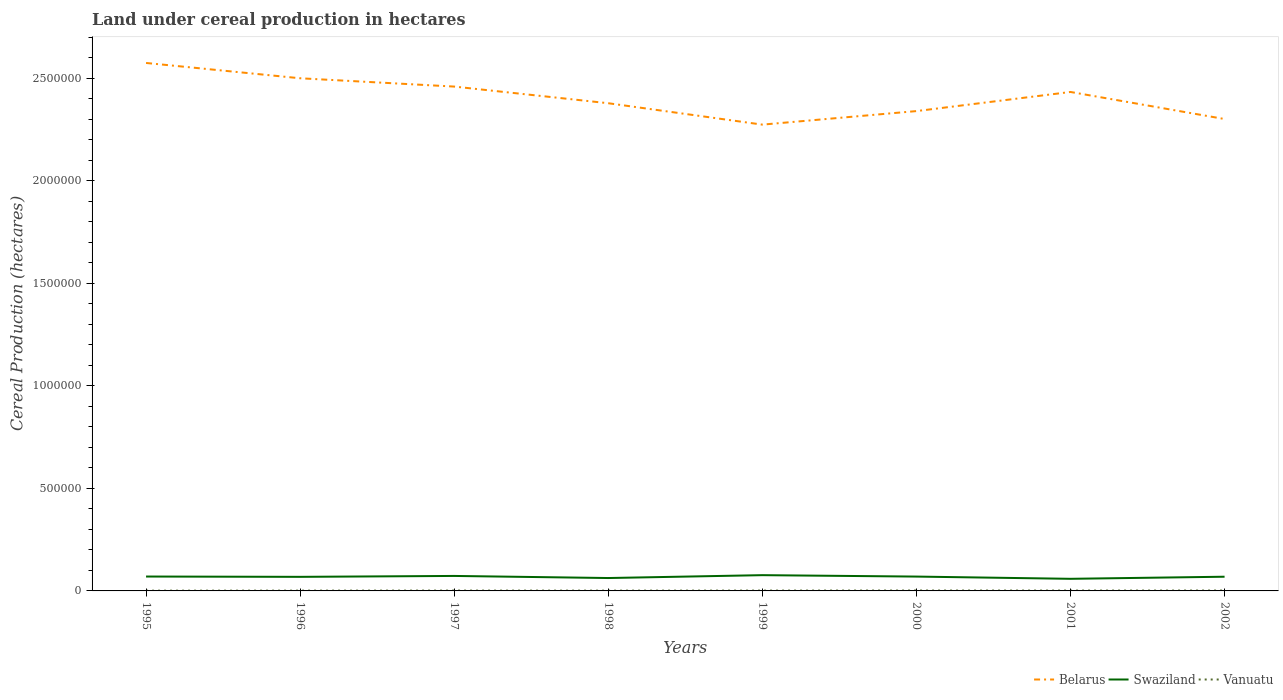How many different coloured lines are there?
Make the answer very short. 3. Across all years, what is the maximum land under cereal production in Swaziland?
Offer a terse response. 5.90e+04. What is the total land under cereal production in Belarus in the graph?
Provide a succinct answer. 1.99e+05. What is the difference between the highest and the second highest land under cereal production in Vanuatu?
Ensure brevity in your answer.  650. What is the difference between the highest and the lowest land under cereal production in Swaziland?
Your answer should be compact. 5. Is the land under cereal production in Swaziland strictly greater than the land under cereal production in Vanuatu over the years?
Give a very brief answer. No. How many lines are there?
Make the answer very short. 3. How many years are there in the graph?
Your response must be concise. 8. Are the values on the major ticks of Y-axis written in scientific E-notation?
Your answer should be very brief. No. Where does the legend appear in the graph?
Provide a short and direct response. Bottom right. How are the legend labels stacked?
Your answer should be very brief. Horizontal. What is the title of the graph?
Make the answer very short. Land under cereal production in hectares. What is the label or title of the Y-axis?
Offer a terse response. Cereal Production (hectares). What is the Cereal Production (hectares) in Belarus in 1995?
Offer a very short reply. 2.57e+06. What is the Cereal Production (hectares) in Swaziland in 1995?
Provide a short and direct response. 7.01e+04. What is the Cereal Production (hectares) of Vanuatu in 1995?
Provide a succinct answer. 1306. What is the Cereal Production (hectares) of Belarus in 1996?
Your answer should be very brief. 2.50e+06. What is the Cereal Production (hectares) of Swaziland in 1996?
Offer a terse response. 6.87e+04. What is the Cereal Production (hectares) of Vanuatu in 1996?
Ensure brevity in your answer.  1466. What is the Cereal Production (hectares) of Belarus in 1997?
Offer a terse response. 2.46e+06. What is the Cereal Production (hectares) in Swaziland in 1997?
Ensure brevity in your answer.  7.30e+04. What is the Cereal Production (hectares) of Vanuatu in 1997?
Offer a terse response. 1693. What is the Cereal Production (hectares) of Belarus in 1998?
Your answer should be very brief. 2.38e+06. What is the Cereal Production (hectares) in Swaziland in 1998?
Your response must be concise. 6.28e+04. What is the Cereal Production (hectares) in Vanuatu in 1998?
Keep it short and to the point. 1458. What is the Cereal Production (hectares) in Belarus in 1999?
Make the answer very short. 2.27e+06. What is the Cereal Production (hectares) in Swaziland in 1999?
Provide a succinct answer. 7.68e+04. What is the Cereal Production (hectares) in Vanuatu in 1999?
Provide a short and direct response. 1672. What is the Cereal Production (hectares) in Belarus in 2000?
Make the answer very short. 2.34e+06. What is the Cereal Production (hectares) in Swaziland in 2000?
Keep it short and to the point. 6.99e+04. What is the Cereal Production (hectares) in Vanuatu in 2000?
Give a very brief answer. 1956. What is the Cereal Production (hectares) in Belarus in 2001?
Offer a very short reply. 2.43e+06. What is the Cereal Production (hectares) in Swaziland in 2001?
Your response must be concise. 5.90e+04. What is the Cereal Production (hectares) of Vanuatu in 2001?
Make the answer very short. 1781. What is the Cereal Production (hectares) in Belarus in 2002?
Provide a short and direct response. 2.30e+06. What is the Cereal Production (hectares) in Swaziland in 2002?
Your response must be concise. 6.92e+04. What is the Cereal Production (hectares) of Vanuatu in 2002?
Ensure brevity in your answer.  1902. Across all years, what is the maximum Cereal Production (hectares) in Belarus?
Your answer should be compact. 2.57e+06. Across all years, what is the maximum Cereal Production (hectares) in Swaziland?
Make the answer very short. 7.68e+04. Across all years, what is the maximum Cereal Production (hectares) in Vanuatu?
Make the answer very short. 1956. Across all years, what is the minimum Cereal Production (hectares) of Belarus?
Your response must be concise. 2.27e+06. Across all years, what is the minimum Cereal Production (hectares) of Swaziland?
Provide a short and direct response. 5.90e+04. Across all years, what is the minimum Cereal Production (hectares) of Vanuatu?
Provide a short and direct response. 1306. What is the total Cereal Production (hectares) of Belarus in the graph?
Offer a terse response. 1.93e+07. What is the total Cereal Production (hectares) of Swaziland in the graph?
Provide a short and direct response. 5.50e+05. What is the total Cereal Production (hectares) in Vanuatu in the graph?
Offer a very short reply. 1.32e+04. What is the difference between the Cereal Production (hectares) of Belarus in 1995 and that in 1996?
Your response must be concise. 7.46e+04. What is the difference between the Cereal Production (hectares) of Swaziland in 1995 and that in 1996?
Offer a terse response. 1472. What is the difference between the Cereal Production (hectares) in Vanuatu in 1995 and that in 1996?
Provide a short and direct response. -160. What is the difference between the Cereal Production (hectares) in Belarus in 1995 and that in 1997?
Your response must be concise. 1.15e+05. What is the difference between the Cereal Production (hectares) of Swaziland in 1995 and that in 1997?
Offer a very short reply. -2895. What is the difference between the Cereal Production (hectares) in Vanuatu in 1995 and that in 1997?
Keep it short and to the point. -387. What is the difference between the Cereal Production (hectares) of Belarus in 1995 and that in 1998?
Your response must be concise. 1.96e+05. What is the difference between the Cereal Production (hectares) in Swaziland in 1995 and that in 1998?
Make the answer very short. 7324. What is the difference between the Cereal Production (hectares) of Vanuatu in 1995 and that in 1998?
Keep it short and to the point. -152. What is the difference between the Cereal Production (hectares) in Belarus in 1995 and that in 1999?
Provide a succinct answer. 3.01e+05. What is the difference between the Cereal Production (hectares) of Swaziland in 1995 and that in 1999?
Your answer should be very brief. -6715. What is the difference between the Cereal Production (hectares) in Vanuatu in 1995 and that in 1999?
Keep it short and to the point. -366. What is the difference between the Cereal Production (hectares) of Belarus in 1995 and that in 2000?
Provide a succinct answer. 2.35e+05. What is the difference between the Cereal Production (hectares) in Swaziland in 1995 and that in 2000?
Provide a succinct answer. 229. What is the difference between the Cereal Production (hectares) in Vanuatu in 1995 and that in 2000?
Make the answer very short. -650. What is the difference between the Cereal Production (hectares) of Belarus in 1995 and that in 2001?
Ensure brevity in your answer.  1.41e+05. What is the difference between the Cereal Production (hectares) of Swaziland in 1995 and that in 2001?
Your answer should be very brief. 1.11e+04. What is the difference between the Cereal Production (hectares) in Vanuatu in 1995 and that in 2001?
Your answer should be very brief. -475. What is the difference between the Cereal Production (hectares) of Belarus in 1995 and that in 2002?
Provide a succinct answer. 2.73e+05. What is the difference between the Cereal Production (hectares) in Swaziland in 1995 and that in 2002?
Ensure brevity in your answer.  881. What is the difference between the Cereal Production (hectares) of Vanuatu in 1995 and that in 2002?
Your answer should be compact. -596. What is the difference between the Cereal Production (hectares) in Belarus in 1996 and that in 1997?
Provide a short and direct response. 4.05e+04. What is the difference between the Cereal Production (hectares) of Swaziland in 1996 and that in 1997?
Provide a short and direct response. -4367. What is the difference between the Cereal Production (hectares) in Vanuatu in 1996 and that in 1997?
Give a very brief answer. -227. What is the difference between the Cereal Production (hectares) of Belarus in 1996 and that in 1998?
Provide a short and direct response. 1.22e+05. What is the difference between the Cereal Production (hectares) of Swaziland in 1996 and that in 1998?
Your response must be concise. 5852. What is the difference between the Cereal Production (hectares) of Vanuatu in 1996 and that in 1998?
Offer a very short reply. 8. What is the difference between the Cereal Production (hectares) of Belarus in 1996 and that in 1999?
Offer a terse response. 2.26e+05. What is the difference between the Cereal Production (hectares) in Swaziland in 1996 and that in 1999?
Provide a succinct answer. -8187. What is the difference between the Cereal Production (hectares) in Vanuatu in 1996 and that in 1999?
Your answer should be very brief. -206. What is the difference between the Cereal Production (hectares) of Swaziland in 1996 and that in 2000?
Keep it short and to the point. -1243. What is the difference between the Cereal Production (hectares) in Vanuatu in 1996 and that in 2000?
Your answer should be very brief. -490. What is the difference between the Cereal Production (hectares) in Belarus in 1996 and that in 2001?
Provide a short and direct response. 6.68e+04. What is the difference between the Cereal Production (hectares) in Swaziland in 1996 and that in 2001?
Your response must be concise. 9651. What is the difference between the Cereal Production (hectares) of Vanuatu in 1996 and that in 2001?
Provide a succinct answer. -315. What is the difference between the Cereal Production (hectares) in Belarus in 1996 and that in 2002?
Provide a succinct answer. 1.99e+05. What is the difference between the Cereal Production (hectares) of Swaziland in 1996 and that in 2002?
Ensure brevity in your answer.  -591. What is the difference between the Cereal Production (hectares) of Vanuatu in 1996 and that in 2002?
Keep it short and to the point. -436. What is the difference between the Cereal Production (hectares) of Belarus in 1997 and that in 1998?
Your response must be concise. 8.12e+04. What is the difference between the Cereal Production (hectares) in Swaziland in 1997 and that in 1998?
Give a very brief answer. 1.02e+04. What is the difference between the Cereal Production (hectares) in Vanuatu in 1997 and that in 1998?
Your response must be concise. 235. What is the difference between the Cereal Production (hectares) in Belarus in 1997 and that in 1999?
Your answer should be very brief. 1.86e+05. What is the difference between the Cereal Production (hectares) in Swaziland in 1997 and that in 1999?
Provide a succinct answer. -3820. What is the difference between the Cereal Production (hectares) of Vanuatu in 1997 and that in 1999?
Provide a short and direct response. 21. What is the difference between the Cereal Production (hectares) in Belarus in 1997 and that in 2000?
Your answer should be compact. 1.20e+05. What is the difference between the Cereal Production (hectares) of Swaziland in 1997 and that in 2000?
Make the answer very short. 3124. What is the difference between the Cereal Production (hectares) in Vanuatu in 1997 and that in 2000?
Your answer should be compact. -263. What is the difference between the Cereal Production (hectares) of Belarus in 1997 and that in 2001?
Offer a terse response. 2.63e+04. What is the difference between the Cereal Production (hectares) of Swaziland in 1997 and that in 2001?
Keep it short and to the point. 1.40e+04. What is the difference between the Cereal Production (hectares) of Vanuatu in 1997 and that in 2001?
Keep it short and to the point. -88. What is the difference between the Cereal Production (hectares) of Belarus in 1997 and that in 2002?
Ensure brevity in your answer.  1.58e+05. What is the difference between the Cereal Production (hectares) in Swaziland in 1997 and that in 2002?
Your answer should be very brief. 3776. What is the difference between the Cereal Production (hectares) in Vanuatu in 1997 and that in 2002?
Offer a terse response. -209. What is the difference between the Cereal Production (hectares) in Belarus in 1998 and that in 1999?
Offer a terse response. 1.04e+05. What is the difference between the Cereal Production (hectares) of Swaziland in 1998 and that in 1999?
Make the answer very short. -1.40e+04. What is the difference between the Cereal Production (hectares) of Vanuatu in 1998 and that in 1999?
Keep it short and to the point. -214. What is the difference between the Cereal Production (hectares) of Belarus in 1998 and that in 2000?
Provide a succinct answer. 3.83e+04. What is the difference between the Cereal Production (hectares) of Swaziland in 1998 and that in 2000?
Offer a very short reply. -7095. What is the difference between the Cereal Production (hectares) in Vanuatu in 1998 and that in 2000?
Ensure brevity in your answer.  -498. What is the difference between the Cereal Production (hectares) of Belarus in 1998 and that in 2001?
Give a very brief answer. -5.49e+04. What is the difference between the Cereal Production (hectares) of Swaziland in 1998 and that in 2001?
Offer a very short reply. 3799. What is the difference between the Cereal Production (hectares) of Vanuatu in 1998 and that in 2001?
Your response must be concise. -323. What is the difference between the Cereal Production (hectares) of Belarus in 1998 and that in 2002?
Your answer should be compact. 7.70e+04. What is the difference between the Cereal Production (hectares) of Swaziland in 1998 and that in 2002?
Make the answer very short. -6443. What is the difference between the Cereal Production (hectares) in Vanuatu in 1998 and that in 2002?
Provide a short and direct response. -444. What is the difference between the Cereal Production (hectares) in Belarus in 1999 and that in 2000?
Give a very brief answer. -6.60e+04. What is the difference between the Cereal Production (hectares) in Swaziland in 1999 and that in 2000?
Make the answer very short. 6944. What is the difference between the Cereal Production (hectares) of Vanuatu in 1999 and that in 2000?
Your answer should be very brief. -284. What is the difference between the Cereal Production (hectares) in Belarus in 1999 and that in 2001?
Your answer should be very brief. -1.59e+05. What is the difference between the Cereal Production (hectares) in Swaziland in 1999 and that in 2001?
Keep it short and to the point. 1.78e+04. What is the difference between the Cereal Production (hectares) of Vanuatu in 1999 and that in 2001?
Make the answer very short. -109. What is the difference between the Cereal Production (hectares) of Belarus in 1999 and that in 2002?
Offer a very short reply. -2.73e+04. What is the difference between the Cereal Production (hectares) of Swaziland in 1999 and that in 2002?
Ensure brevity in your answer.  7596. What is the difference between the Cereal Production (hectares) of Vanuatu in 1999 and that in 2002?
Offer a terse response. -230. What is the difference between the Cereal Production (hectares) of Belarus in 2000 and that in 2001?
Provide a short and direct response. -9.32e+04. What is the difference between the Cereal Production (hectares) in Swaziland in 2000 and that in 2001?
Your response must be concise. 1.09e+04. What is the difference between the Cereal Production (hectares) in Vanuatu in 2000 and that in 2001?
Make the answer very short. 175. What is the difference between the Cereal Production (hectares) of Belarus in 2000 and that in 2002?
Offer a terse response. 3.87e+04. What is the difference between the Cereal Production (hectares) of Swaziland in 2000 and that in 2002?
Provide a short and direct response. 652. What is the difference between the Cereal Production (hectares) of Belarus in 2001 and that in 2002?
Keep it short and to the point. 1.32e+05. What is the difference between the Cereal Production (hectares) in Swaziland in 2001 and that in 2002?
Offer a terse response. -1.02e+04. What is the difference between the Cereal Production (hectares) of Vanuatu in 2001 and that in 2002?
Ensure brevity in your answer.  -121. What is the difference between the Cereal Production (hectares) of Belarus in 1995 and the Cereal Production (hectares) of Swaziland in 1996?
Make the answer very short. 2.50e+06. What is the difference between the Cereal Production (hectares) in Belarus in 1995 and the Cereal Production (hectares) in Vanuatu in 1996?
Offer a terse response. 2.57e+06. What is the difference between the Cereal Production (hectares) of Swaziland in 1995 and the Cereal Production (hectares) of Vanuatu in 1996?
Your answer should be compact. 6.87e+04. What is the difference between the Cereal Production (hectares) in Belarus in 1995 and the Cereal Production (hectares) in Swaziland in 1997?
Make the answer very short. 2.50e+06. What is the difference between the Cereal Production (hectares) in Belarus in 1995 and the Cereal Production (hectares) in Vanuatu in 1997?
Your answer should be very brief. 2.57e+06. What is the difference between the Cereal Production (hectares) in Swaziland in 1995 and the Cereal Production (hectares) in Vanuatu in 1997?
Provide a succinct answer. 6.84e+04. What is the difference between the Cereal Production (hectares) in Belarus in 1995 and the Cereal Production (hectares) in Swaziland in 1998?
Ensure brevity in your answer.  2.51e+06. What is the difference between the Cereal Production (hectares) in Belarus in 1995 and the Cereal Production (hectares) in Vanuatu in 1998?
Your response must be concise. 2.57e+06. What is the difference between the Cereal Production (hectares) in Swaziland in 1995 and the Cereal Production (hectares) in Vanuatu in 1998?
Give a very brief answer. 6.87e+04. What is the difference between the Cereal Production (hectares) of Belarus in 1995 and the Cereal Production (hectares) of Swaziland in 1999?
Provide a succinct answer. 2.50e+06. What is the difference between the Cereal Production (hectares) of Belarus in 1995 and the Cereal Production (hectares) of Vanuatu in 1999?
Make the answer very short. 2.57e+06. What is the difference between the Cereal Production (hectares) in Swaziland in 1995 and the Cereal Production (hectares) in Vanuatu in 1999?
Your answer should be compact. 6.85e+04. What is the difference between the Cereal Production (hectares) in Belarus in 1995 and the Cereal Production (hectares) in Swaziland in 2000?
Give a very brief answer. 2.50e+06. What is the difference between the Cereal Production (hectares) of Belarus in 1995 and the Cereal Production (hectares) of Vanuatu in 2000?
Your answer should be very brief. 2.57e+06. What is the difference between the Cereal Production (hectares) in Swaziland in 1995 and the Cereal Production (hectares) in Vanuatu in 2000?
Keep it short and to the point. 6.82e+04. What is the difference between the Cereal Production (hectares) of Belarus in 1995 and the Cereal Production (hectares) of Swaziland in 2001?
Your answer should be very brief. 2.51e+06. What is the difference between the Cereal Production (hectares) of Belarus in 1995 and the Cereal Production (hectares) of Vanuatu in 2001?
Offer a terse response. 2.57e+06. What is the difference between the Cereal Production (hectares) of Swaziland in 1995 and the Cereal Production (hectares) of Vanuatu in 2001?
Your response must be concise. 6.83e+04. What is the difference between the Cereal Production (hectares) in Belarus in 1995 and the Cereal Production (hectares) in Swaziland in 2002?
Your answer should be compact. 2.50e+06. What is the difference between the Cereal Production (hectares) of Belarus in 1995 and the Cereal Production (hectares) of Vanuatu in 2002?
Your answer should be very brief. 2.57e+06. What is the difference between the Cereal Production (hectares) of Swaziland in 1995 and the Cereal Production (hectares) of Vanuatu in 2002?
Make the answer very short. 6.82e+04. What is the difference between the Cereal Production (hectares) in Belarus in 1996 and the Cereal Production (hectares) in Swaziland in 1997?
Keep it short and to the point. 2.43e+06. What is the difference between the Cereal Production (hectares) in Belarus in 1996 and the Cereal Production (hectares) in Vanuatu in 1997?
Ensure brevity in your answer.  2.50e+06. What is the difference between the Cereal Production (hectares) of Swaziland in 1996 and the Cereal Production (hectares) of Vanuatu in 1997?
Keep it short and to the point. 6.70e+04. What is the difference between the Cereal Production (hectares) in Belarus in 1996 and the Cereal Production (hectares) in Swaziland in 1998?
Ensure brevity in your answer.  2.44e+06. What is the difference between the Cereal Production (hectares) of Belarus in 1996 and the Cereal Production (hectares) of Vanuatu in 1998?
Ensure brevity in your answer.  2.50e+06. What is the difference between the Cereal Production (hectares) of Swaziland in 1996 and the Cereal Production (hectares) of Vanuatu in 1998?
Ensure brevity in your answer.  6.72e+04. What is the difference between the Cereal Production (hectares) in Belarus in 1996 and the Cereal Production (hectares) in Swaziland in 1999?
Provide a short and direct response. 2.42e+06. What is the difference between the Cereal Production (hectares) of Belarus in 1996 and the Cereal Production (hectares) of Vanuatu in 1999?
Keep it short and to the point. 2.50e+06. What is the difference between the Cereal Production (hectares) in Swaziland in 1996 and the Cereal Production (hectares) in Vanuatu in 1999?
Offer a terse response. 6.70e+04. What is the difference between the Cereal Production (hectares) in Belarus in 1996 and the Cereal Production (hectares) in Swaziland in 2000?
Provide a succinct answer. 2.43e+06. What is the difference between the Cereal Production (hectares) of Belarus in 1996 and the Cereal Production (hectares) of Vanuatu in 2000?
Give a very brief answer. 2.50e+06. What is the difference between the Cereal Production (hectares) of Swaziland in 1996 and the Cereal Production (hectares) of Vanuatu in 2000?
Your response must be concise. 6.67e+04. What is the difference between the Cereal Production (hectares) of Belarus in 1996 and the Cereal Production (hectares) of Swaziland in 2001?
Ensure brevity in your answer.  2.44e+06. What is the difference between the Cereal Production (hectares) of Belarus in 1996 and the Cereal Production (hectares) of Vanuatu in 2001?
Ensure brevity in your answer.  2.50e+06. What is the difference between the Cereal Production (hectares) in Swaziland in 1996 and the Cereal Production (hectares) in Vanuatu in 2001?
Give a very brief answer. 6.69e+04. What is the difference between the Cereal Production (hectares) in Belarus in 1996 and the Cereal Production (hectares) in Swaziland in 2002?
Give a very brief answer. 2.43e+06. What is the difference between the Cereal Production (hectares) of Belarus in 1996 and the Cereal Production (hectares) of Vanuatu in 2002?
Provide a short and direct response. 2.50e+06. What is the difference between the Cereal Production (hectares) of Swaziland in 1996 and the Cereal Production (hectares) of Vanuatu in 2002?
Make the answer very short. 6.68e+04. What is the difference between the Cereal Production (hectares) in Belarus in 1997 and the Cereal Production (hectares) in Swaziland in 1998?
Your answer should be very brief. 2.40e+06. What is the difference between the Cereal Production (hectares) in Belarus in 1997 and the Cereal Production (hectares) in Vanuatu in 1998?
Make the answer very short. 2.46e+06. What is the difference between the Cereal Production (hectares) of Swaziland in 1997 and the Cereal Production (hectares) of Vanuatu in 1998?
Provide a succinct answer. 7.16e+04. What is the difference between the Cereal Production (hectares) in Belarus in 1997 and the Cereal Production (hectares) in Swaziland in 1999?
Your response must be concise. 2.38e+06. What is the difference between the Cereal Production (hectares) of Belarus in 1997 and the Cereal Production (hectares) of Vanuatu in 1999?
Keep it short and to the point. 2.46e+06. What is the difference between the Cereal Production (hectares) of Swaziland in 1997 and the Cereal Production (hectares) of Vanuatu in 1999?
Your response must be concise. 7.13e+04. What is the difference between the Cereal Production (hectares) of Belarus in 1997 and the Cereal Production (hectares) of Swaziland in 2000?
Ensure brevity in your answer.  2.39e+06. What is the difference between the Cereal Production (hectares) in Belarus in 1997 and the Cereal Production (hectares) in Vanuatu in 2000?
Provide a short and direct response. 2.46e+06. What is the difference between the Cereal Production (hectares) of Swaziland in 1997 and the Cereal Production (hectares) of Vanuatu in 2000?
Give a very brief answer. 7.11e+04. What is the difference between the Cereal Production (hectares) in Belarus in 1997 and the Cereal Production (hectares) in Swaziland in 2001?
Your answer should be very brief. 2.40e+06. What is the difference between the Cereal Production (hectares) in Belarus in 1997 and the Cereal Production (hectares) in Vanuatu in 2001?
Provide a short and direct response. 2.46e+06. What is the difference between the Cereal Production (hectares) in Swaziland in 1997 and the Cereal Production (hectares) in Vanuatu in 2001?
Ensure brevity in your answer.  7.12e+04. What is the difference between the Cereal Production (hectares) in Belarus in 1997 and the Cereal Production (hectares) in Swaziland in 2002?
Your response must be concise. 2.39e+06. What is the difference between the Cereal Production (hectares) of Belarus in 1997 and the Cereal Production (hectares) of Vanuatu in 2002?
Your answer should be very brief. 2.46e+06. What is the difference between the Cereal Production (hectares) of Swaziland in 1997 and the Cereal Production (hectares) of Vanuatu in 2002?
Ensure brevity in your answer.  7.11e+04. What is the difference between the Cereal Production (hectares) in Belarus in 1998 and the Cereal Production (hectares) in Swaziland in 1999?
Your answer should be very brief. 2.30e+06. What is the difference between the Cereal Production (hectares) of Belarus in 1998 and the Cereal Production (hectares) of Vanuatu in 1999?
Your answer should be very brief. 2.38e+06. What is the difference between the Cereal Production (hectares) in Swaziland in 1998 and the Cereal Production (hectares) in Vanuatu in 1999?
Provide a succinct answer. 6.11e+04. What is the difference between the Cereal Production (hectares) in Belarus in 1998 and the Cereal Production (hectares) in Swaziland in 2000?
Offer a terse response. 2.31e+06. What is the difference between the Cereal Production (hectares) of Belarus in 1998 and the Cereal Production (hectares) of Vanuatu in 2000?
Your response must be concise. 2.38e+06. What is the difference between the Cereal Production (hectares) of Swaziland in 1998 and the Cereal Production (hectares) of Vanuatu in 2000?
Offer a terse response. 6.08e+04. What is the difference between the Cereal Production (hectares) of Belarus in 1998 and the Cereal Production (hectares) of Swaziland in 2001?
Your answer should be very brief. 2.32e+06. What is the difference between the Cereal Production (hectares) in Belarus in 1998 and the Cereal Production (hectares) in Vanuatu in 2001?
Your answer should be very brief. 2.38e+06. What is the difference between the Cereal Production (hectares) in Swaziland in 1998 and the Cereal Production (hectares) in Vanuatu in 2001?
Offer a very short reply. 6.10e+04. What is the difference between the Cereal Production (hectares) of Belarus in 1998 and the Cereal Production (hectares) of Swaziland in 2002?
Your answer should be very brief. 2.31e+06. What is the difference between the Cereal Production (hectares) in Belarus in 1998 and the Cereal Production (hectares) in Vanuatu in 2002?
Your answer should be very brief. 2.38e+06. What is the difference between the Cereal Production (hectares) in Swaziland in 1998 and the Cereal Production (hectares) in Vanuatu in 2002?
Provide a short and direct response. 6.09e+04. What is the difference between the Cereal Production (hectares) in Belarus in 1999 and the Cereal Production (hectares) in Swaziland in 2000?
Keep it short and to the point. 2.20e+06. What is the difference between the Cereal Production (hectares) of Belarus in 1999 and the Cereal Production (hectares) of Vanuatu in 2000?
Your answer should be compact. 2.27e+06. What is the difference between the Cereal Production (hectares) of Swaziland in 1999 and the Cereal Production (hectares) of Vanuatu in 2000?
Your answer should be compact. 7.49e+04. What is the difference between the Cereal Production (hectares) in Belarus in 1999 and the Cereal Production (hectares) in Swaziland in 2001?
Keep it short and to the point. 2.21e+06. What is the difference between the Cereal Production (hectares) of Belarus in 1999 and the Cereal Production (hectares) of Vanuatu in 2001?
Make the answer very short. 2.27e+06. What is the difference between the Cereal Production (hectares) in Swaziland in 1999 and the Cereal Production (hectares) in Vanuatu in 2001?
Give a very brief answer. 7.51e+04. What is the difference between the Cereal Production (hectares) of Belarus in 1999 and the Cereal Production (hectares) of Swaziland in 2002?
Offer a terse response. 2.20e+06. What is the difference between the Cereal Production (hectares) of Belarus in 1999 and the Cereal Production (hectares) of Vanuatu in 2002?
Your answer should be very brief. 2.27e+06. What is the difference between the Cereal Production (hectares) of Swaziland in 1999 and the Cereal Production (hectares) of Vanuatu in 2002?
Provide a succinct answer. 7.49e+04. What is the difference between the Cereal Production (hectares) in Belarus in 2000 and the Cereal Production (hectares) in Swaziland in 2001?
Offer a very short reply. 2.28e+06. What is the difference between the Cereal Production (hectares) in Belarus in 2000 and the Cereal Production (hectares) in Vanuatu in 2001?
Offer a terse response. 2.34e+06. What is the difference between the Cereal Production (hectares) in Swaziland in 2000 and the Cereal Production (hectares) in Vanuatu in 2001?
Give a very brief answer. 6.81e+04. What is the difference between the Cereal Production (hectares) of Belarus in 2000 and the Cereal Production (hectares) of Swaziland in 2002?
Ensure brevity in your answer.  2.27e+06. What is the difference between the Cereal Production (hectares) in Belarus in 2000 and the Cereal Production (hectares) in Vanuatu in 2002?
Your answer should be very brief. 2.34e+06. What is the difference between the Cereal Production (hectares) of Swaziland in 2000 and the Cereal Production (hectares) of Vanuatu in 2002?
Your answer should be very brief. 6.80e+04. What is the difference between the Cereal Production (hectares) in Belarus in 2001 and the Cereal Production (hectares) in Swaziland in 2002?
Ensure brevity in your answer.  2.36e+06. What is the difference between the Cereal Production (hectares) of Belarus in 2001 and the Cereal Production (hectares) of Vanuatu in 2002?
Make the answer very short. 2.43e+06. What is the difference between the Cereal Production (hectares) of Swaziland in 2001 and the Cereal Production (hectares) of Vanuatu in 2002?
Your response must be concise. 5.71e+04. What is the average Cereal Production (hectares) of Belarus per year?
Keep it short and to the point. 2.41e+06. What is the average Cereal Production (hectares) of Swaziland per year?
Make the answer very short. 6.87e+04. What is the average Cereal Production (hectares) in Vanuatu per year?
Your answer should be very brief. 1654.25. In the year 1995, what is the difference between the Cereal Production (hectares) of Belarus and Cereal Production (hectares) of Swaziland?
Your response must be concise. 2.50e+06. In the year 1995, what is the difference between the Cereal Production (hectares) in Belarus and Cereal Production (hectares) in Vanuatu?
Your response must be concise. 2.57e+06. In the year 1995, what is the difference between the Cereal Production (hectares) of Swaziland and Cereal Production (hectares) of Vanuatu?
Provide a succinct answer. 6.88e+04. In the year 1996, what is the difference between the Cereal Production (hectares) of Belarus and Cereal Production (hectares) of Swaziland?
Your answer should be compact. 2.43e+06. In the year 1996, what is the difference between the Cereal Production (hectares) in Belarus and Cereal Production (hectares) in Vanuatu?
Give a very brief answer. 2.50e+06. In the year 1996, what is the difference between the Cereal Production (hectares) of Swaziland and Cereal Production (hectares) of Vanuatu?
Your response must be concise. 6.72e+04. In the year 1997, what is the difference between the Cereal Production (hectares) of Belarus and Cereal Production (hectares) of Swaziland?
Your answer should be compact. 2.39e+06. In the year 1997, what is the difference between the Cereal Production (hectares) of Belarus and Cereal Production (hectares) of Vanuatu?
Your answer should be very brief. 2.46e+06. In the year 1997, what is the difference between the Cereal Production (hectares) in Swaziland and Cereal Production (hectares) in Vanuatu?
Offer a very short reply. 7.13e+04. In the year 1998, what is the difference between the Cereal Production (hectares) in Belarus and Cereal Production (hectares) in Swaziland?
Offer a very short reply. 2.31e+06. In the year 1998, what is the difference between the Cereal Production (hectares) of Belarus and Cereal Production (hectares) of Vanuatu?
Your answer should be very brief. 2.38e+06. In the year 1998, what is the difference between the Cereal Production (hectares) of Swaziland and Cereal Production (hectares) of Vanuatu?
Give a very brief answer. 6.13e+04. In the year 1999, what is the difference between the Cereal Production (hectares) in Belarus and Cereal Production (hectares) in Swaziland?
Your answer should be compact. 2.20e+06. In the year 1999, what is the difference between the Cereal Production (hectares) in Belarus and Cereal Production (hectares) in Vanuatu?
Your answer should be compact. 2.27e+06. In the year 1999, what is the difference between the Cereal Production (hectares) of Swaziland and Cereal Production (hectares) of Vanuatu?
Provide a short and direct response. 7.52e+04. In the year 2000, what is the difference between the Cereal Production (hectares) in Belarus and Cereal Production (hectares) in Swaziland?
Provide a succinct answer. 2.27e+06. In the year 2000, what is the difference between the Cereal Production (hectares) in Belarus and Cereal Production (hectares) in Vanuatu?
Make the answer very short. 2.34e+06. In the year 2000, what is the difference between the Cereal Production (hectares) in Swaziland and Cereal Production (hectares) in Vanuatu?
Your answer should be very brief. 6.79e+04. In the year 2001, what is the difference between the Cereal Production (hectares) in Belarus and Cereal Production (hectares) in Swaziland?
Your response must be concise. 2.37e+06. In the year 2001, what is the difference between the Cereal Production (hectares) of Belarus and Cereal Production (hectares) of Vanuatu?
Ensure brevity in your answer.  2.43e+06. In the year 2001, what is the difference between the Cereal Production (hectares) of Swaziland and Cereal Production (hectares) of Vanuatu?
Give a very brief answer. 5.72e+04. In the year 2002, what is the difference between the Cereal Production (hectares) of Belarus and Cereal Production (hectares) of Swaziland?
Offer a very short reply. 2.23e+06. In the year 2002, what is the difference between the Cereal Production (hectares) in Belarus and Cereal Production (hectares) in Vanuatu?
Give a very brief answer. 2.30e+06. In the year 2002, what is the difference between the Cereal Production (hectares) in Swaziland and Cereal Production (hectares) in Vanuatu?
Offer a terse response. 6.73e+04. What is the ratio of the Cereal Production (hectares) in Belarus in 1995 to that in 1996?
Make the answer very short. 1.03. What is the ratio of the Cereal Production (hectares) in Swaziland in 1995 to that in 1996?
Provide a short and direct response. 1.02. What is the ratio of the Cereal Production (hectares) of Vanuatu in 1995 to that in 1996?
Give a very brief answer. 0.89. What is the ratio of the Cereal Production (hectares) of Belarus in 1995 to that in 1997?
Offer a terse response. 1.05. What is the ratio of the Cereal Production (hectares) of Swaziland in 1995 to that in 1997?
Offer a terse response. 0.96. What is the ratio of the Cereal Production (hectares) of Vanuatu in 1995 to that in 1997?
Provide a succinct answer. 0.77. What is the ratio of the Cereal Production (hectares) of Belarus in 1995 to that in 1998?
Ensure brevity in your answer.  1.08. What is the ratio of the Cereal Production (hectares) in Swaziland in 1995 to that in 1998?
Your response must be concise. 1.12. What is the ratio of the Cereal Production (hectares) in Vanuatu in 1995 to that in 1998?
Your answer should be compact. 0.9. What is the ratio of the Cereal Production (hectares) of Belarus in 1995 to that in 1999?
Ensure brevity in your answer.  1.13. What is the ratio of the Cereal Production (hectares) in Swaziland in 1995 to that in 1999?
Offer a very short reply. 0.91. What is the ratio of the Cereal Production (hectares) of Vanuatu in 1995 to that in 1999?
Provide a succinct answer. 0.78. What is the ratio of the Cereal Production (hectares) of Belarus in 1995 to that in 2000?
Offer a very short reply. 1.1. What is the ratio of the Cereal Production (hectares) in Vanuatu in 1995 to that in 2000?
Ensure brevity in your answer.  0.67. What is the ratio of the Cereal Production (hectares) of Belarus in 1995 to that in 2001?
Make the answer very short. 1.06. What is the ratio of the Cereal Production (hectares) of Swaziland in 1995 to that in 2001?
Provide a succinct answer. 1.19. What is the ratio of the Cereal Production (hectares) in Vanuatu in 1995 to that in 2001?
Ensure brevity in your answer.  0.73. What is the ratio of the Cereal Production (hectares) in Belarus in 1995 to that in 2002?
Make the answer very short. 1.12. What is the ratio of the Cereal Production (hectares) in Swaziland in 1995 to that in 2002?
Your response must be concise. 1.01. What is the ratio of the Cereal Production (hectares) of Vanuatu in 1995 to that in 2002?
Make the answer very short. 0.69. What is the ratio of the Cereal Production (hectares) of Belarus in 1996 to that in 1997?
Make the answer very short. 1.02. What is the ratio of the Cereal Production (hectares) of Swaziland in 1996 to that in 1997?
Provide a short and direct response. 0.94. What is the ratio of the Cereal Production (hectares) in Vanuatu in 1996 to that in 1997?
Your answer should be compact. 0.87. What is the ratio of the Cereal Production (hectares) in Belarus in 1996 to that in 1998?
Provide a succinct answer. 1.05. What is the ratio of the Cereal Production (hectares) in Swaziland in 1996 to that in 1998?
Provide a succinct answer. 1.09. What is the ratio of the Cereal Production (hectares) in Vanuatu in 1996 to that in 1998?
Provide a succinct answer. 1.01. What is the ratio of the Cereal Production (hectares) in Belarus in 1996 to that in 1999?
Your response must be concise. 1.1. What is the ratio of the Cereal Production (hectares) of Swaziland in 1996 to that in 1999?
Make the answer very short. 0.89. What is the ratio of the Cereal Production (hectares) of Vanuatu in 1996 to that in 1999?
Your response must be concise. 0.88. What is the ratio of the Cereal Production (hectares) in Belarus in 1996 to that in 2000?
Give a very brief answer. 1.07. What is the ratio of the Cereal Production (hectares) of Swaziland in 1996 to that in 2000?
Make the answer very short. 0.98. What is the ratio of the Cereal Production (hectares) of Vanuatu in 1996 to that in 2000?
Keep it short and to the point. 0.75. What is the ratio of the Cereal Production (hectares) in Belarus in 1996 to that in 2001?
Ensure brevity in your answer.  1.03. What is the ratio of the Cereal Production (hectares) of Swaziland in 1996 to that in 2001?
Make the answer very short. 1.16. What is the ratio of the Cereal Production (hectares) in Vanuatu in 1996 to that in 2001?
Give a very brief answer. 0.82. What is the ratio of the Cereal Production (hectares) in Belarus in 1996 to that in 2002?
Give a very brief answer. 1.09. What is the ratio of the Cereal Production (hectares) of Vanuatu in 1996 to that in 2002?
Keep it short and to the point. 0.77. What is the ratio of the Cereal Production (hectares) in Belarus in 1997 to that in 1998?
Give a very brief answer. 1.03. What is the ratio of the Cereal Production (hectares) of Swaziland in 1997 to that in 1998?
Provide a succinct answer. 1.16. What is the ratio of the Cereal Production (hectares) in Vanuatu in 1997 to that in 1998?
Make the answer very short. 1.16. What is the ratio of the Cereal Production (hectares) of Belarus in 1997 to that in 1999?
Make the answer very short. 1.08. What is the ratio of the Cereal Production (hectares) of Swaziland in 1997 to that in 1999?
Offer a very short reply. 0.95. What is the ratio of the Cereal Production (hectares) of Vanuatu in 1997 to that in 1999?
Your response must be concise. 1.01. What is the ratio of the Cereal Production (hectares) of Belarus in 1997 to that in 2000?
Offer a very short reply. 1.05. What is the ratio of the Cereal Production (hectares) in Swaziland in 1997 to that in 2000?
Give a very brief answer. 1.04. What is the ratio of the Cereal Production (hectares) in Vanuatu in 1997 to that in 2000?
Keep it short and to the point. 0.87. What is the ratio of the Cereal Production (hectares) of Belarus in 1997 to that in 2001?
Offer a terse response. 1.01. What is the ratio of the Cereal Production (hectares) of Swaziland in 1997 to that in 2001?
Your answer should be very brief. 1.24. What is the ratio of the Cereal Production (hectares) of Vanuatu in 1997 to that in 2001?
Provide a succinct answer. 0.95. What is the ratio of the Cereal Production (hectares) in Belarus in 1997 to that in 2002?
Provide a short and direct response. 1.07. What is the ratio of the Cereal Production (hectares) of Swaziland in 1997 to that in 2002?
Your answer should be very brief. 1.05. What is the ratio of the Cereal Production (hectares) in Vanuatu in 1997 to that in 2002?
Your response must be concise. 0.89. What is the ratio of the Cereal Production (hectares) of Belarus in 1998 to that in 1999?
Offer a very short reply. 1.05. What is the ratio of the Cereal Production (hectares) of Swaziland in 1998 to that in 1999?
Keep it short and to the point. 0.82. What is the ratio of the Cereal Production (hectares) of Vanuatu in 1998 to that in 1999?
Offer a terse response. 0.87. What is the ratio of the Cereal Production (hectares) in Belarus in 1998 to that in 2000?
Give a very brief answer. 1.02. What is the ratio of the Cereal Production (hectares) of Swaziland in 1998 to that in 2000?
Your answer should be very brief. 0.9. What is the ratio of the Cereal Production (hectares) of Vanuatu in 1998 to that in 2000?
Provide a short and direct response. 0.75. What is the ratio of the Cereal Production (hectares) in Belarus in 1998 to that in 2001?
Give a very brief answer. 0.98. What is the ratio of the Cereal Production (hectares) in Swaziland in 1998 to that in 2001?
Ensure brevity in your answer.  1.06. What is the ratio of the Cereal Production (hectares) in Vanuatu in 1998 to that in 2001?
Ensure brevity in your answer.  0.82. What is the ratio of the Cereal Production (hectares) in Belarus in 1998 to that in 2002?
Keep it short and to the point. 1.03. What is the ratio of the Cereal Production (hectares) of Swaziland in 1998 to that in 2002?
Make the answer very short. 0.91. What is the ratio of the Cereal Production (hectares) of Vanuatu in 1998 to that in 2002?
Make the answer very short. 0.77. What is the ratio of the Cereal Production (hectares) of Belarus in 1999 to that in 2000?
Provide a short and direct response. 0.97. What is the ratio of the Cereal Production (hectares) of Swaziland in 1999 to that in 2000?
Your answer should be very brief. 1.1. What is the ratio of the Cereal Production (hectares) in Vanuatu in 1999 to that in 2000?
Keep it short and to the point. 0.85. What is the ratio of the Cereal Production (hectares) of Belarus in 1999 to that in 2001?
Keep it short and to the point. 0.93. What is the ratio of the Cereal Production (hectares) in Swaziland in 1999 to that in 2001?
Provide a short and direct response. 1.3. What is the ratio of the Cereal Production (hectares) in Vanuatu in 1999 to that in 2001?
Offer a terse response. 0.94. What is the ratio of the Cereal Production (hectares) in Belarus in 1999 to that in 2002?
Your answer should be very brief. 0.99. What is the ratio of the Cereal Production (hectares) in Swaziland in 1999 to that in 2002?
Give a very brief answer. 1.11. What is the ratio of the Cereal Production (hectares) of Vanuatu in 1999 to that in 2002?
Provide a short and direct response. 0.88. What is the ratio of the Cereal Production (hectares) of Belarus in 2000 to that in 2001?
Provide a short and direct response. 0.96. What is the ratio of the Cereal Production (hectares) of Swaziland in 2000 to that in 2001?
Your response must be concise. 1.18. What is the ratio of the Cereal Production (hectares) in Vanuatu in 2000 to that in 2001?
Offer a terse response. 1.1. What is the ratio of the Cereal Production (hectares) in Belarus in 2000 to that in 2002?
Offer a very short reply. 1.02. What is the ratio of the Cereal Production (hectares) in Swaziland in 2000 to that in 2002?
Your answer should be very brief. 1.01. What is the ratio of the Cereal Production (hectares) of Vanuatu in 2000 to that in 2002?
Your response must be concise. 1.03. What is the ratio of the Cereal Production (hectares) of Belarus in 2001 to that in 2002?
Offer a terse response. 1.06. What is the ratio of the Cereal Production (hectares) in Swaziland in 2001 to that in 2002?
Offer a very short reply. 0.85. What is the ratio of the Cereal Production (hectares) of Vanuatu in 2001 to that in 2002?
Give a very brief answer. 0.94. What is the difference between the highest and the second highest Cereal Production (hectares) of Belarus?
Provide a succinct answer. 7.46e+04. What is the difference between the highest and the second highest Cereal Production (hectares) of Swaziland?
Make the answer very short. 3820. What is the difference between the highest and the second highest Cereal Production (hectares) in Vanuatu?
Keep it short and to the point. 54. What is the difference between the highest and the lowest Cereal Production (hectares) in Belarus?
Ensure brevity in your answer.  3.01e+05. What is the difference between the highest and the lowest Cereal Production (hectares) of Swaziland?
Provide a short and direct response. 1.78e+04. What is the difference between the highest and the lowest Cereal Production (hectares) of Vanuatu?
Provide a short and direct response. 650. 